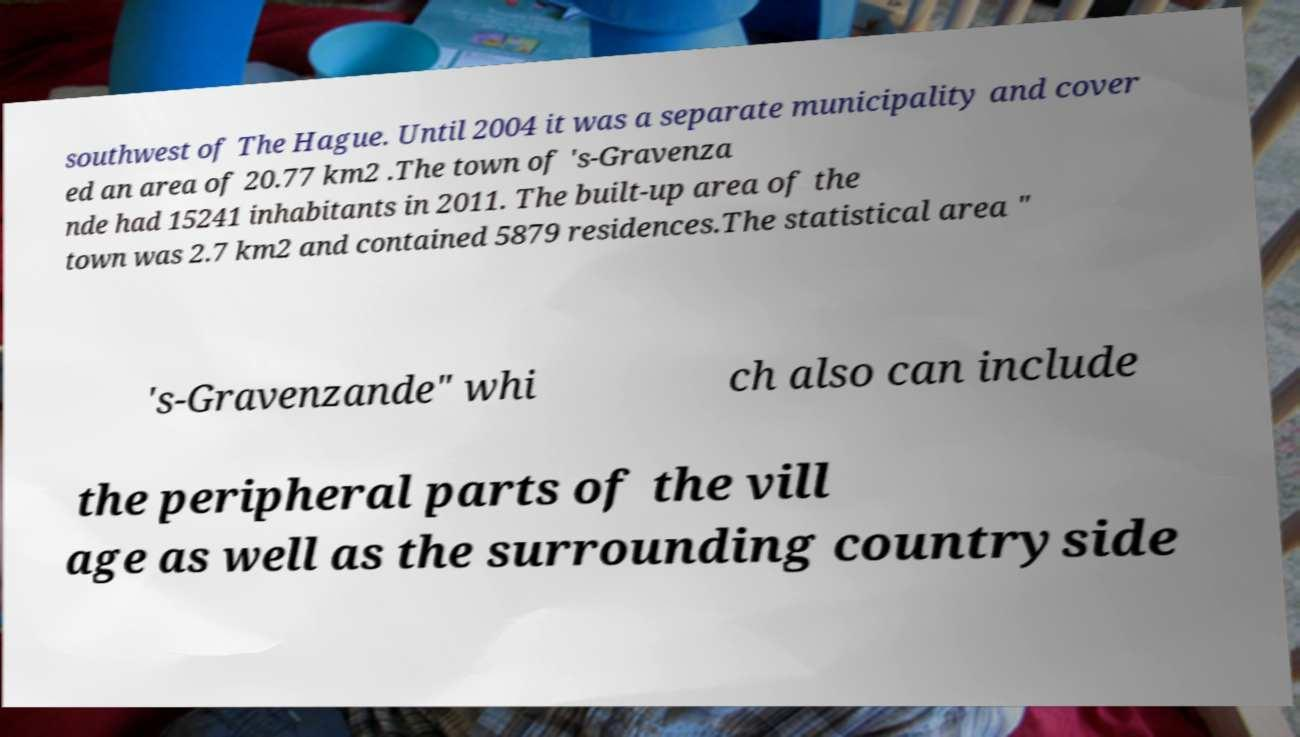Please identify and transcribe the text found in this image. southwest of The Hague. Until 2004 it was a separate municipality and cover ed an area of 20.77 km2 .The town of 's-Gravenza nde had 15241 inhabitants in 2011. The built-up area of the town was 2.7 km2 and contained 5879 residences.The statistical area " 's-Gravenzande" whi ch also can include the peripheral parts of the vill age as well as the surrounding countryside 